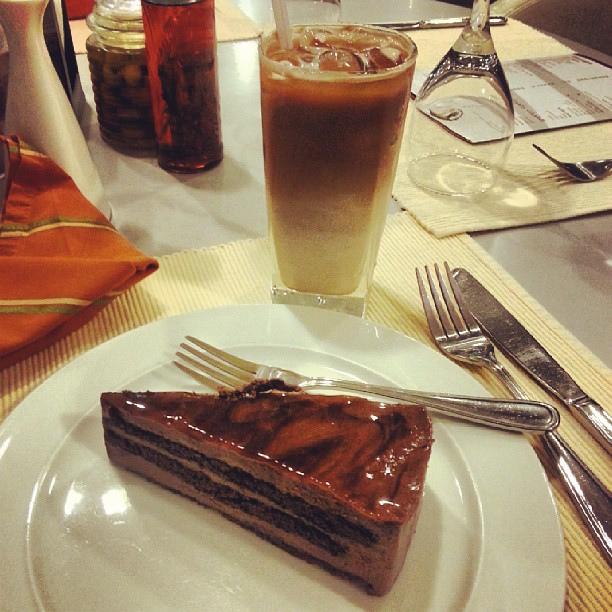Is this a dairy free dessert?
Give a very brief answer. No. How many layers is the pastry?
Be succinct. 7. Is the drink coffee or alcoholic?
Write a very short answer. Coffee. 